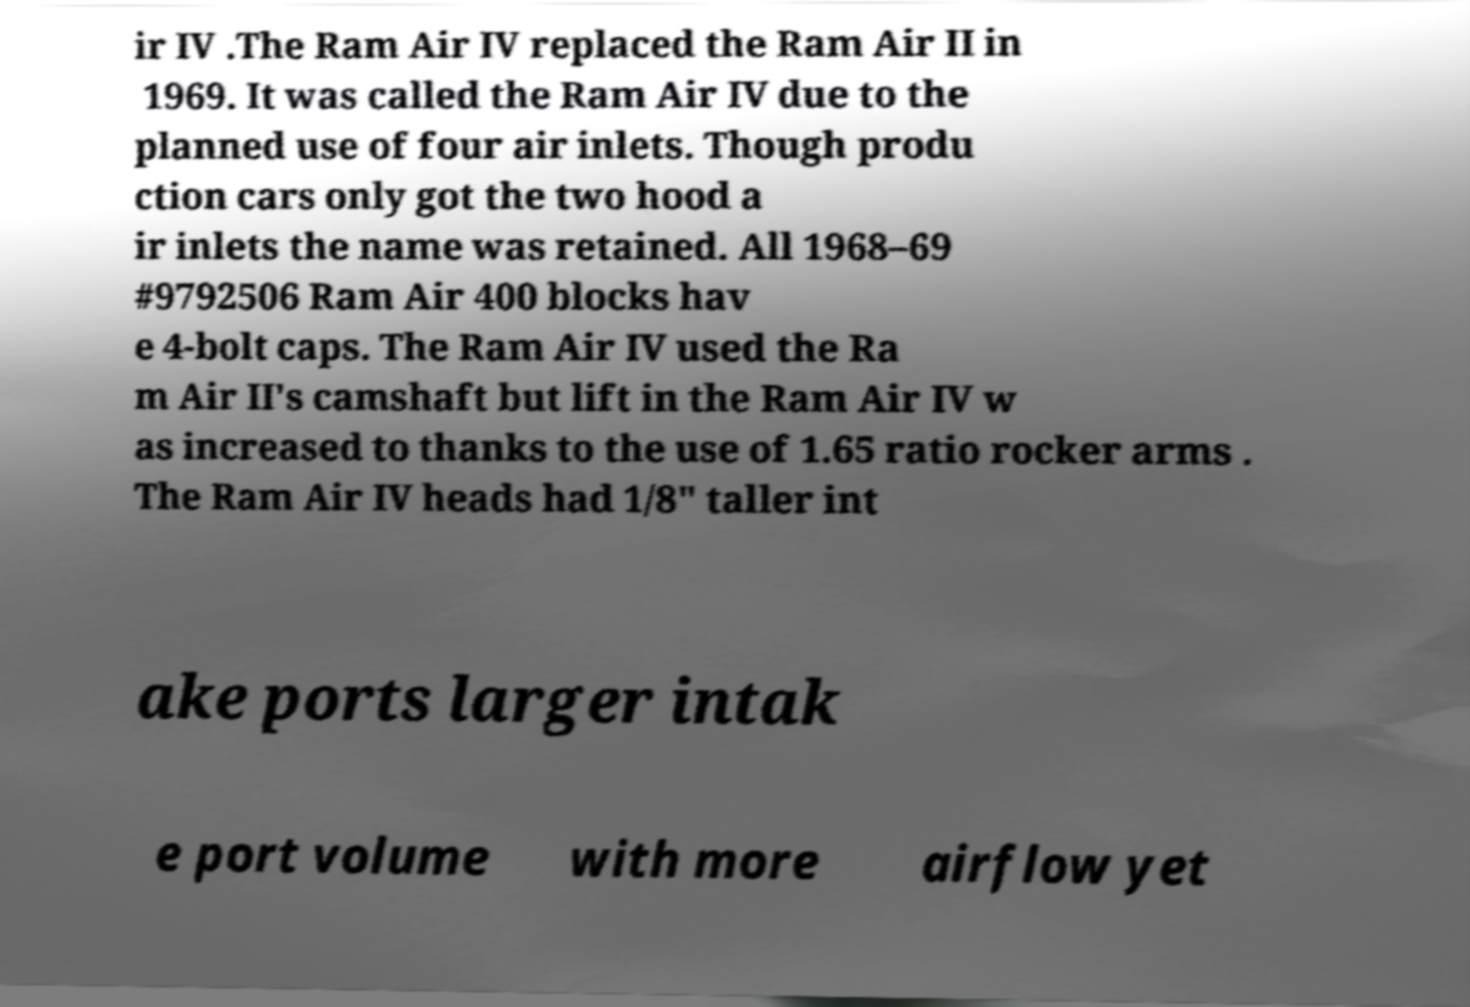Please identify and transcribe the text found in this image. ir IV .The Ram Air IV replaced the Ram Air II in 1969. It was called the Ram Air IV due to the planned use of four air inlets. Though produ ction cars only got the two hood a ir inlets the name was retained. All 1968–69 #9792506 Ram Air 400 blocks hav e 4-bolt caps. The Ram Air IV used the Ra m Air II's camshaft but lift in the Ram Air IV w as increased to thanks to the use of 1.65 ratio rocker arms . The Ram Air IV heads had 1/8" taller int ake ports larger intak e port volume with more airflow yet 